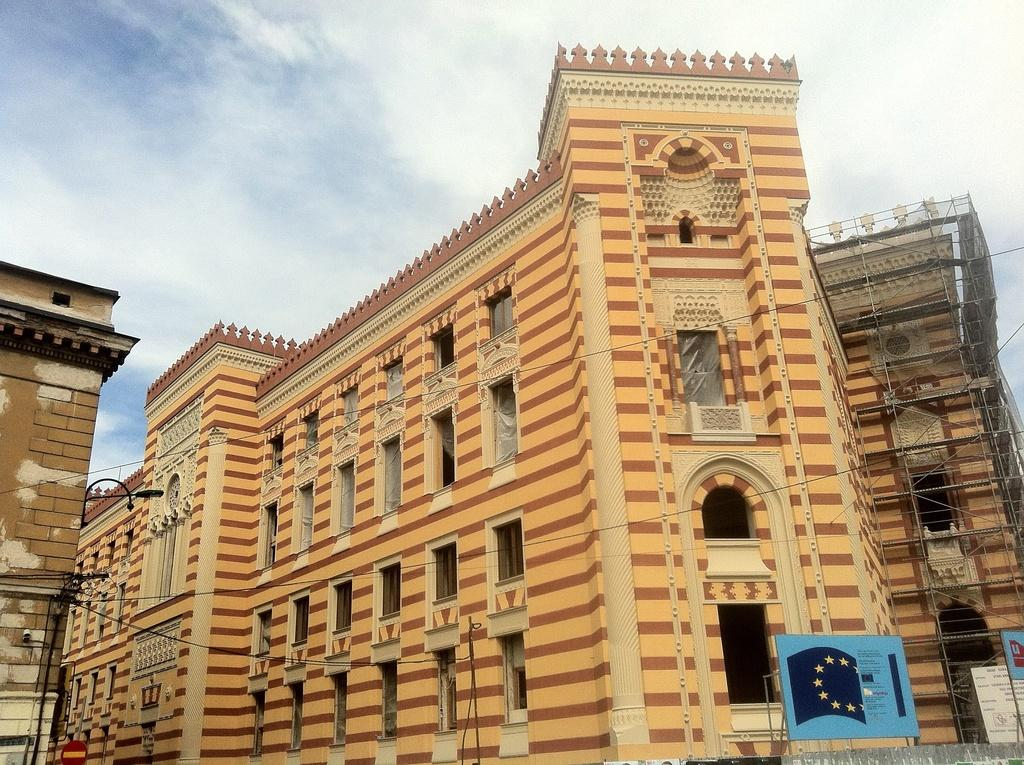What is the main subject of the image? The main subject of the image is a building. What specific features can be observed on the building? The building has windows. Where was the image taken? The image was taken outside. What can be seen at the bottom right of the image? There are boards at the bottom right of the image. What is visible in the sky at the top of the image? There are clouds in the sky at the top of the image. What type of scissors are being used by the pets in the image? There are no pets or scissors present in the image. Can you describe the color of the tongue of the creature in the image? There is no creature or tongue present in the image. 